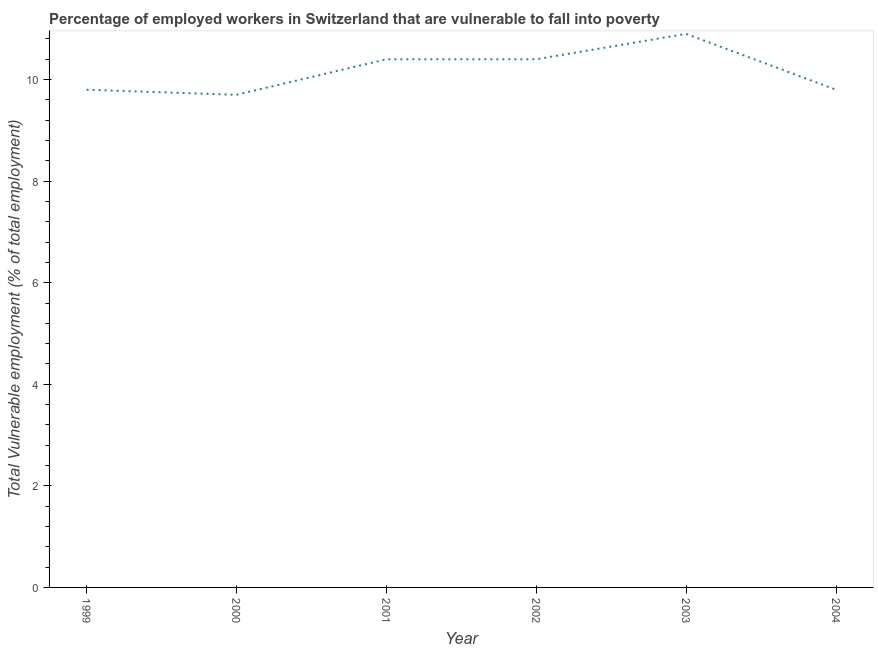What is the total vulnerable employment in 2003?
Keep it short and to the point. 10.9. Across all years, what is the maximum total vulnerable employment?
Your answer should be very brief. 10.9. Across all years, what is the minimum total vulnerable employment?
Your answer should be compact. 9.7. In which year was the total vulnerable employment maximum?
Ensure brevity in your answer.  2003. What is the sum of the total vulnerable employment?
Keep it short and to the point. 61. What is the difference between the total vulnerable employment in 2003 and 2004?
Offer a terse response. 1.1. What is the average total vulnerable employment per year?
Keep it short and to the point. 10.17. What is the median total vulnerable employment?
Keep it short and to the point. 10.1. Do a majority of the years between 1999 and 2004 (inclusive) have total vulnerable employment greater than 10 %?
Offer a very short reply. No. Is the total vulnerable employment in 2001 less than that in 2002?
Offer a very short reply. No. What is the difference between the highest and the lowest total vulnerable employment?
Your answer should be compact. 1.2. In how many years, is the total vulnerable employment greater than the average total vulnerable employment taken over all years?
Your response must be concise. 3. What is the difference between two consecutive major ticks on the Y-axis?
Ensure brevity in your answer.  2. Does the graph contain grids?
Offer a terse response. No. What is the title of the graph?
Provide a succinct answer. Percentage of employed workers in Switzerland that are vulnerable to fall into poverty. What is the label or title of the Y-axis?
Your answer should be very brief. Total Vulnerable employment (% of total employment). What is the Total Vulnerable employment (% of total employment) of 1999?
Your answer should be compact. 9.8. What is the Total Vulnerable employment (% of total employment) in 2000?
Your answer should be compact. 9.7. What is the Total Vulnerable employment (% of total employment) in 2001?
Keep it short and to the point. 10.4. What is the Total Vulnerable employment (% of total employment) in 2002?
Offer a very short reply. 10.4. What is the Total Vulnerable employment (% of total employment) in 2003?
Provide a succinct answer. 10.9. What is the Total Vulnerable employment (% of total employment) of 2004?
Offer a terse response. 9.8. What is the difference between the Total Vulnerable employment (% of total employment) in 1999 and 2000?
Your response must be concise. 0.1. What is the difference between the Total Vulnerable employment (% of total employment) in 1999 and 2002?
Ensure brevity in your answer.  -0.6. What is the difference between the Total Vulnerable employment (% of total employment) in 2000 and 2001?
Make the answer very short. -0.7. What is the difference between the Total Vulnerable employment (% of total employment) in 2000 and 2002?
Your response must be concise. -0.7. What is the difference between the Total Vulnerable employment (% of total employment) in 2000 and 2004?
Ensure brevity in your answer.  -0.1. What is the difference between the Total Vulnerable employment (% of total employment) in 2001 and 2003?
Keep it short and to the point. -0.5. What is the difference between the Total Vulnerable employment (% of total employment) in 2001 and 2004?
Provide a short and direct response. 0.6. What is the difference between the Total Vulnerable employment (% of total employment) in 2002 and 2004?
Ensure brevity in your answer.  0.6. What is the ratio of the Total Vulnerable employment (% of total employment) in 1999 to that in 2000?
Your answer should be compact. 1.01. What is the ratio of the Total Vulnerable employment (% of total employment) in 1999 to that in 2001?
Keep it short and to the point. 0.94. What is the ratio of the Total Vulnerable employment (% of total employment) in 1999 to that in 2002?
Make the answer very short. 0.94. What is the ratio of the Total Vulnerable employment (% of total employment) in 1999 to that in 2003?
Give a very brief answer. 0.9. What is the ratio of the Total Vulnerable employment (% of total employment) in 1999 to that in 2004?
Give a very brief answer. 1. What is the ratio of the Total Vulnerable employment (% of total employment) in 2000 to that in 2001?
Keep it short and to the point. 0.93. What is the ratio of the Total Vulnerable employment (% of total employment) in 2000 to that in 2002?
Provide a short and direct response. 0.93. What is the ratio of the Total Vulnerable employment (% of total employment) in 2000 to that in 2003?
Offer a terse response. 0.89. What is the ratio of the Total Vulnerable employment (% of total employment) in 2001 to that in 2002?
Keep it short and to the point. 1. What is the ratio of the Total Vulnerable employment (% of total employment) in 2001 to that in 2003?
Provide a succinct answer. 0.95. What is the ratio of the Total Vulnerable employment (% of total employment) in 2001 to that in 2004?
Your answer should be compact. 1.06. What is the ratio of the Total Vulnerable employment (% of total employment) in 2002 to that in 2003?
Your answer should be very brief. 0.95. What is the ratio of the Total Vulnerable employment (% of total employment) in 2002 to that in 2004?
Keep it short and to the point. 1.06. What is the ratio of the Total Vulnerable employment (% of total employment) in 2003 to that in 2004?
Your answer should be very brief. 1.11. 